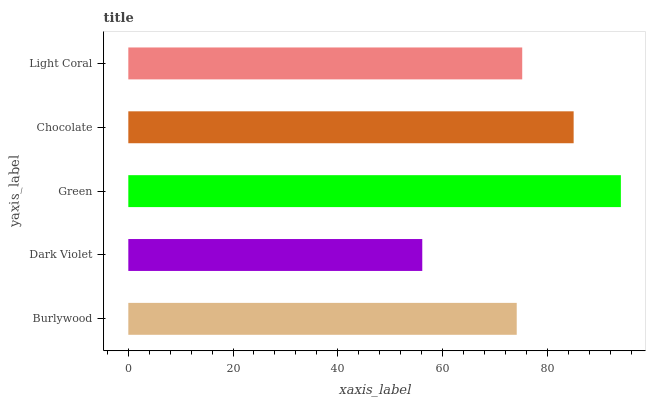Is Dark Violet the minimum?
Answer yes or no. Yes. Is Green the maximum?
Answer yes or no. Yes. Is Green the minimum?
Answer yes or no. No. Is Dark Violet the maximum?
Answer yes or no. No. Is Green greater than Dark Violet?
Answer yes or no. Yes. Is Dark Violet less than Green?
Answer yes or no. Yes. Is Dark Violet greater than Green?
Answer yes or no. No. Is Green less than Dark Violet?
Answer yes or no. No. Is Light Coral the high median?
Answer yes or no. Yes. Is Light Coral the low median?
Answer yes or no. Yes. Is Burlywood the high median?
Answer yes or no. No. Is Green the low median?
Answer yes or no. No. 